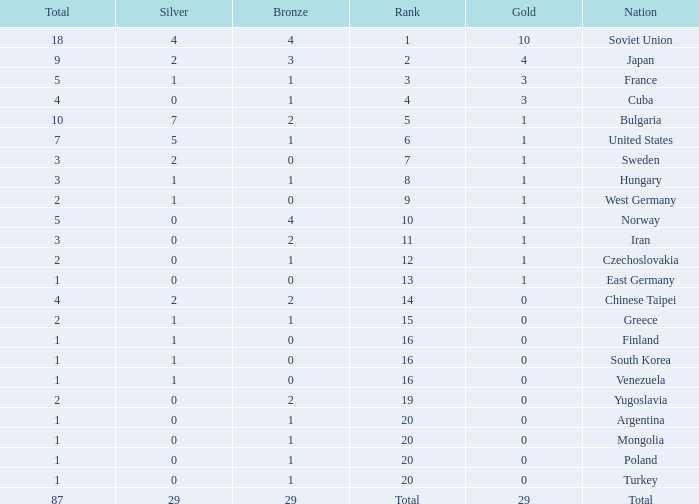Which rank has 1 silver medal and more than 1 gold medal? 3.0. 